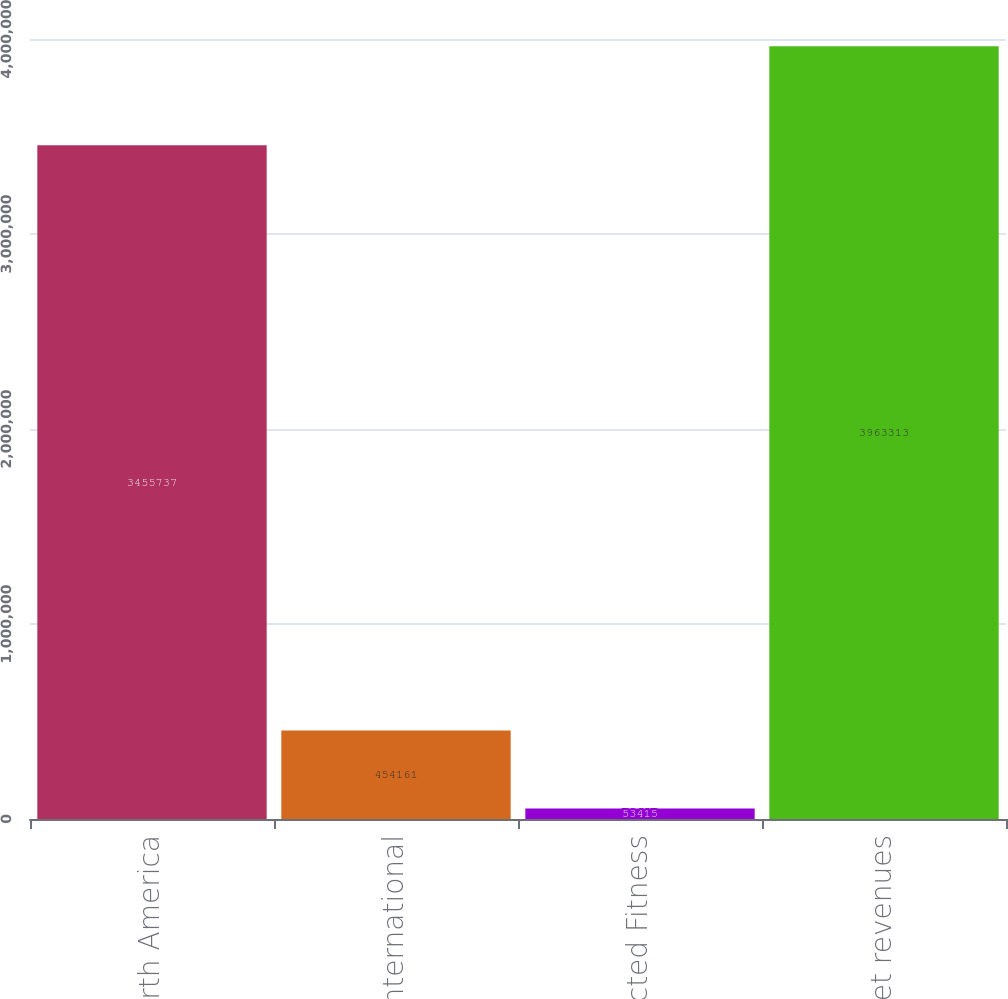<chart> <loc_0><loc_0><loc_500><loc_500><bar_chart><fcel>North America<fcel>International<fcel>Connected Fitness<fcel>Total net revenues<nl><fcel>3.45574e+06<fcel>454161<fcel>53415<fcel>3.96331e+06<nl></chart> 